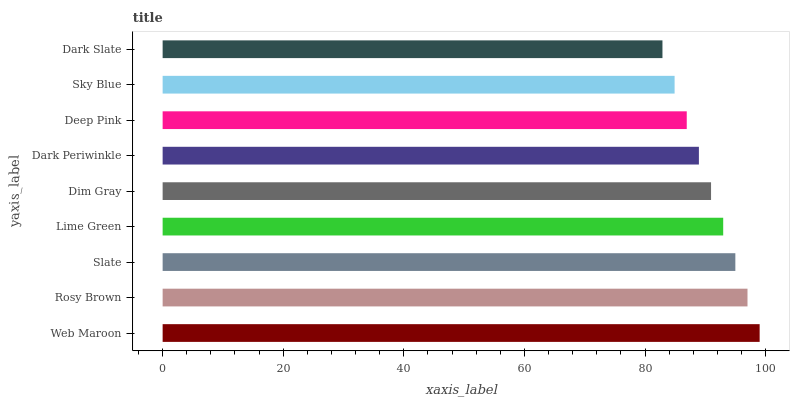Is Dark Slate the minimum?
Answer yes or no. Yes. Is Web Maroon the maximum?
Answer yes or no. Yes. Is Rosy Brown the minimum?
Answer yes or no. No. Is Rosy Brown the maximum?
Answer yes or no. No. Is Web Maroon greater than Rosy Brown?
Answer yes or no. Yes. Is Rosy Brown less than Web Maroon?
Answer yes or no. Yes. Is Rosy Brown greater than Web Maroon?
Answer yes or no. No. Is Web Maroon less than Rosy Brown?
Answer yes or no. No. Is Dim Gray the high median?
Answer yes or no. Yes. Is Dim Gray the low median?
Answer yes or no. Yes. Is Deep Pink the high median?
Answer yes or no. No. Is Slate the low median?
Answer yes or no. No. 